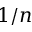Convert formula to latex. <formula><loc_0><loc_0><loc_500><loc_500>1 / n</formula> 